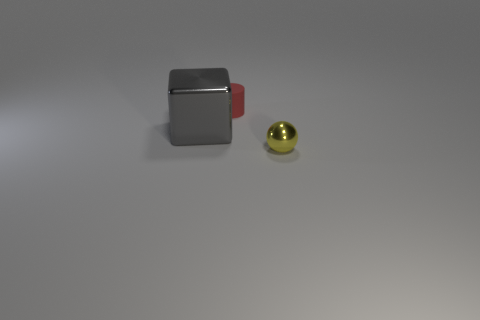Add 2 small brown matte cylinders. How many objects exist? 5 Subtract all balls. How many objects are left? 2 Add 3 large gray rubber cubes. How many large gray rubber cubes exist? 3 Subtract 0 brown balls. How many objects are left? 3 Subtract 1 blocks. How many blocks are left? 0 Subtract all brown cylinders. Subtract all brown cubes. How many cylinders are left? 1 Subtract all small red cylinders. Subtract all small red matte objects. How many objects are left? 1 Add 3 gray metal things. How many gray metal things are left? 4 